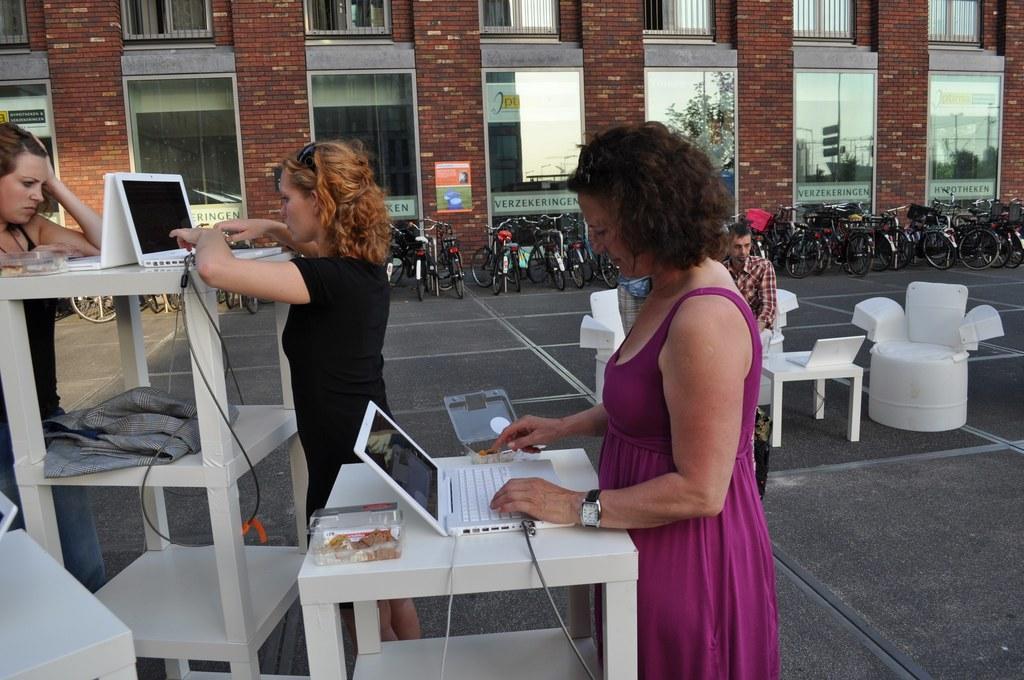Please provide a concise description of this image. In this image there are group of persons who are doing their work and at the background of the image there are cycles and building. 